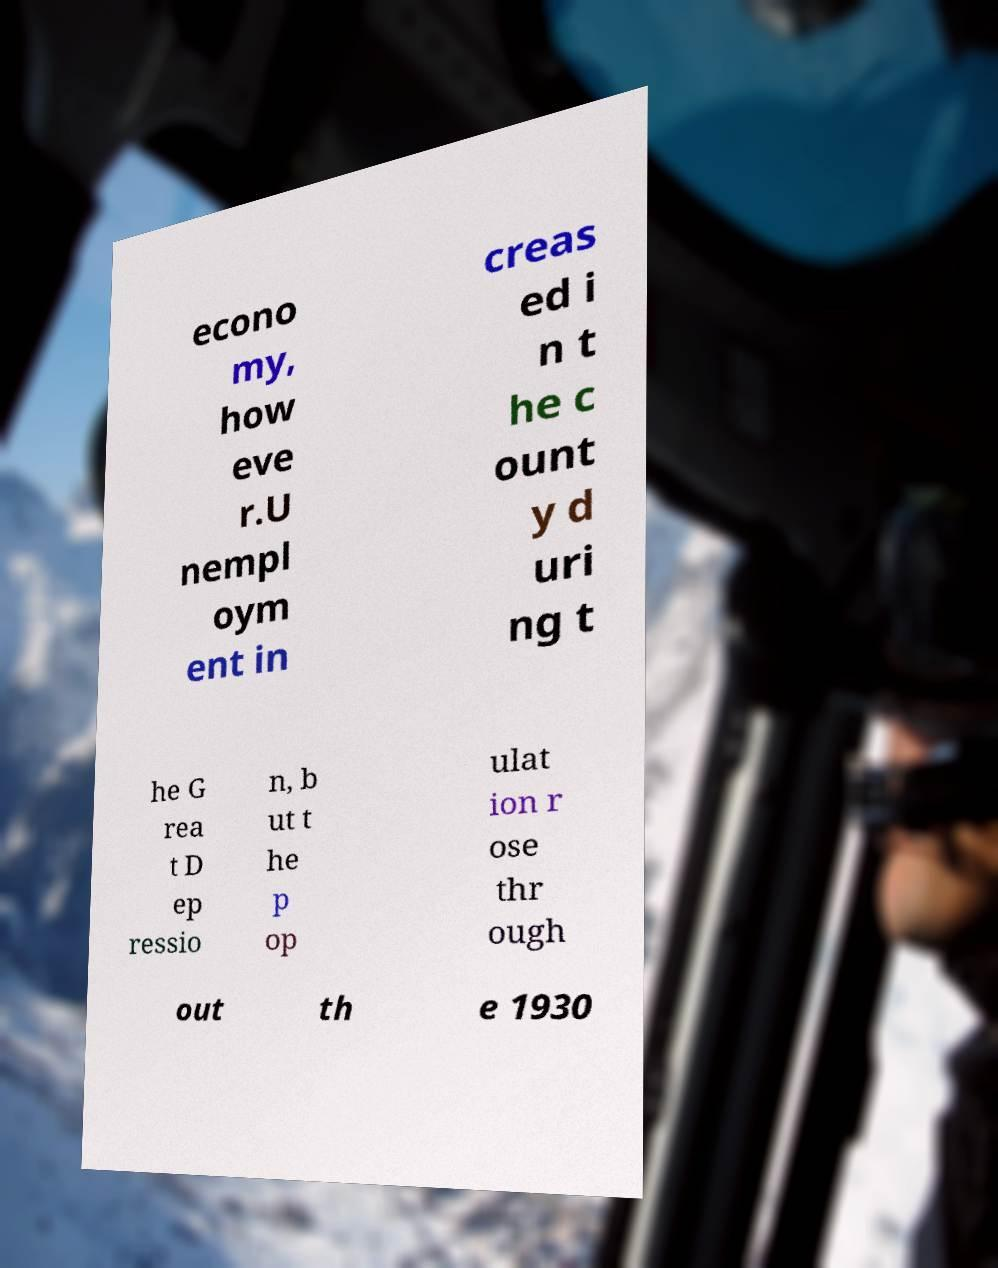Could you extract and type out the text from this image? econo my, how eve r.U nempl oym ent in creas ed i n t he c ount y d uri ng t he G rea t D ep ressio n, b ut t he p op ulat ion r ose thr ough out th e 1930 